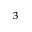<formula> <loc_0><loc_0><loc_500><loc_500>_ { 3 }</formula> 